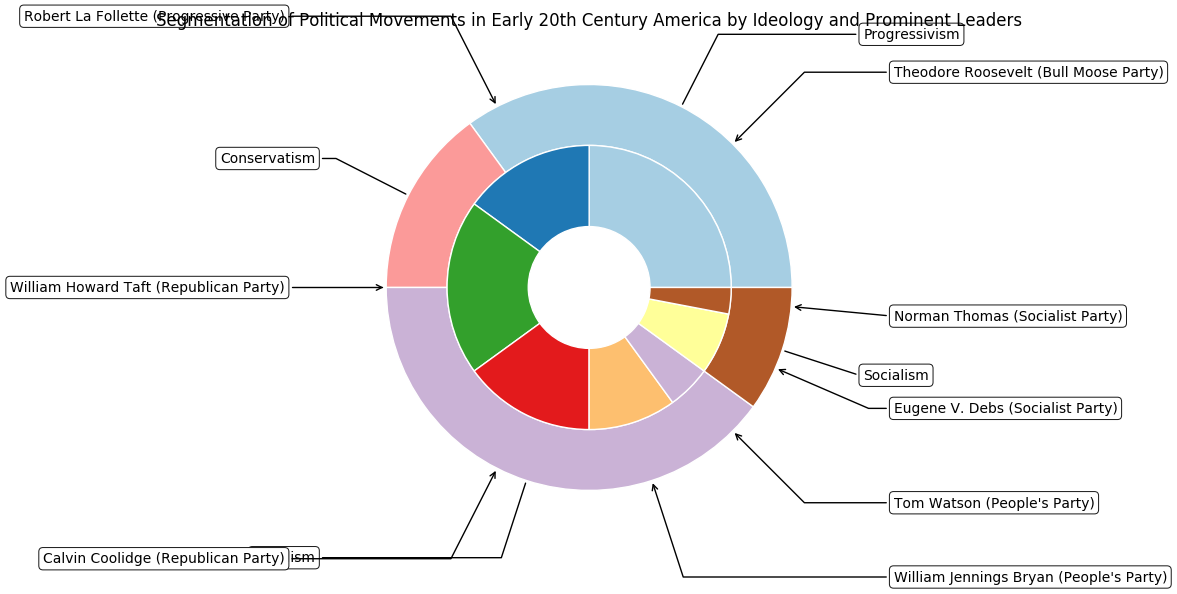Which political ideology holds the largest segment in the early 20th century political movements according to the figure? The outer pie chart represents political ideologies. By observing the segment sizes, Progressivism has the largest portion.
Answer: Progressivism How many more percentage points does Theodore Roosevelt (Bull Moose Party) have compared to Robert La Follette (Progressive Party)? Theodore Roosevelt has 25%, and Robert La Follette has 15%. The difference is 25% - 15% = 10%.
Answer: 10 percentage points Which political leader has the smallest segment, and what is the corresponding ideology and movement? The inner pie chart shows that Norman Thomas has the smallest segment. His ideology is Socialism, and his movement is the Socialist Party.
Answer: Norman Thomas, Socialism, Socialist Party How does the sum of the Populism percentages compare to that of the Socialism percentages? Populism percentages include William Jennings Bryan (10%) and Tom Watson (5%), totaling 10% + 5% = 15%. Socialism percentages include Eugene V. Debs (7%) and Norman Thomas (3%), totaling 7% + 3% = 10%. Populism's total is greater than Socialism's by 5%.
Answer: Populism is greater by 5% What's the combined percentage of the Conservative leaders according to the chart? The conservative leaders are William Howard Taft (20%) and Calvin Coolidge (15%). Combined, they total 20% + 15% = 35%.
Answer: 35% Among the Progressive leaders, who has the larger segment, and by how much? Theodore Roosevelt has 25%, and Robert La Follette has 15%. The difference is 25% - 15% = 10%. Theodore Roosevelt has the larger segment by 10%.
Answer: Theodore Roosevelt, 10% Which ideology has the smallest representation, and what are its significant figures and movements? Socialism has the smallest representation with a total of 10%. The significant figures are Eugene V. Debs (Socialist Party, 7%) and Norman Thomas (Socialist Party, 3%).
Answer: Socialism; Eugene V. Debs and Norman Thomas; Socialist Party How does William Jennings Bryan's segment compare to Calvin Coolidge's in terms of size? William Jennings Bryan (Populism, 10%) and Calvin Coolidge (Conservatism, 15%) are compared. Calvin Coolidge's segment is larger by 15% - 10% = 5%.
Answer: Calvin Coolidge's is larger by 5% What is the ratio of Progressivism's total percentage to Populism's total percentage? Progressivism totals 40% (Theodore Roosevelt 25% + Robert La Follette 15%), and Populism totals 15% (William Jennings Bryan 10% + Tom Watson 5%). The ratio is 40:15, which simplifies to 8:3.
Answer: 8:3 